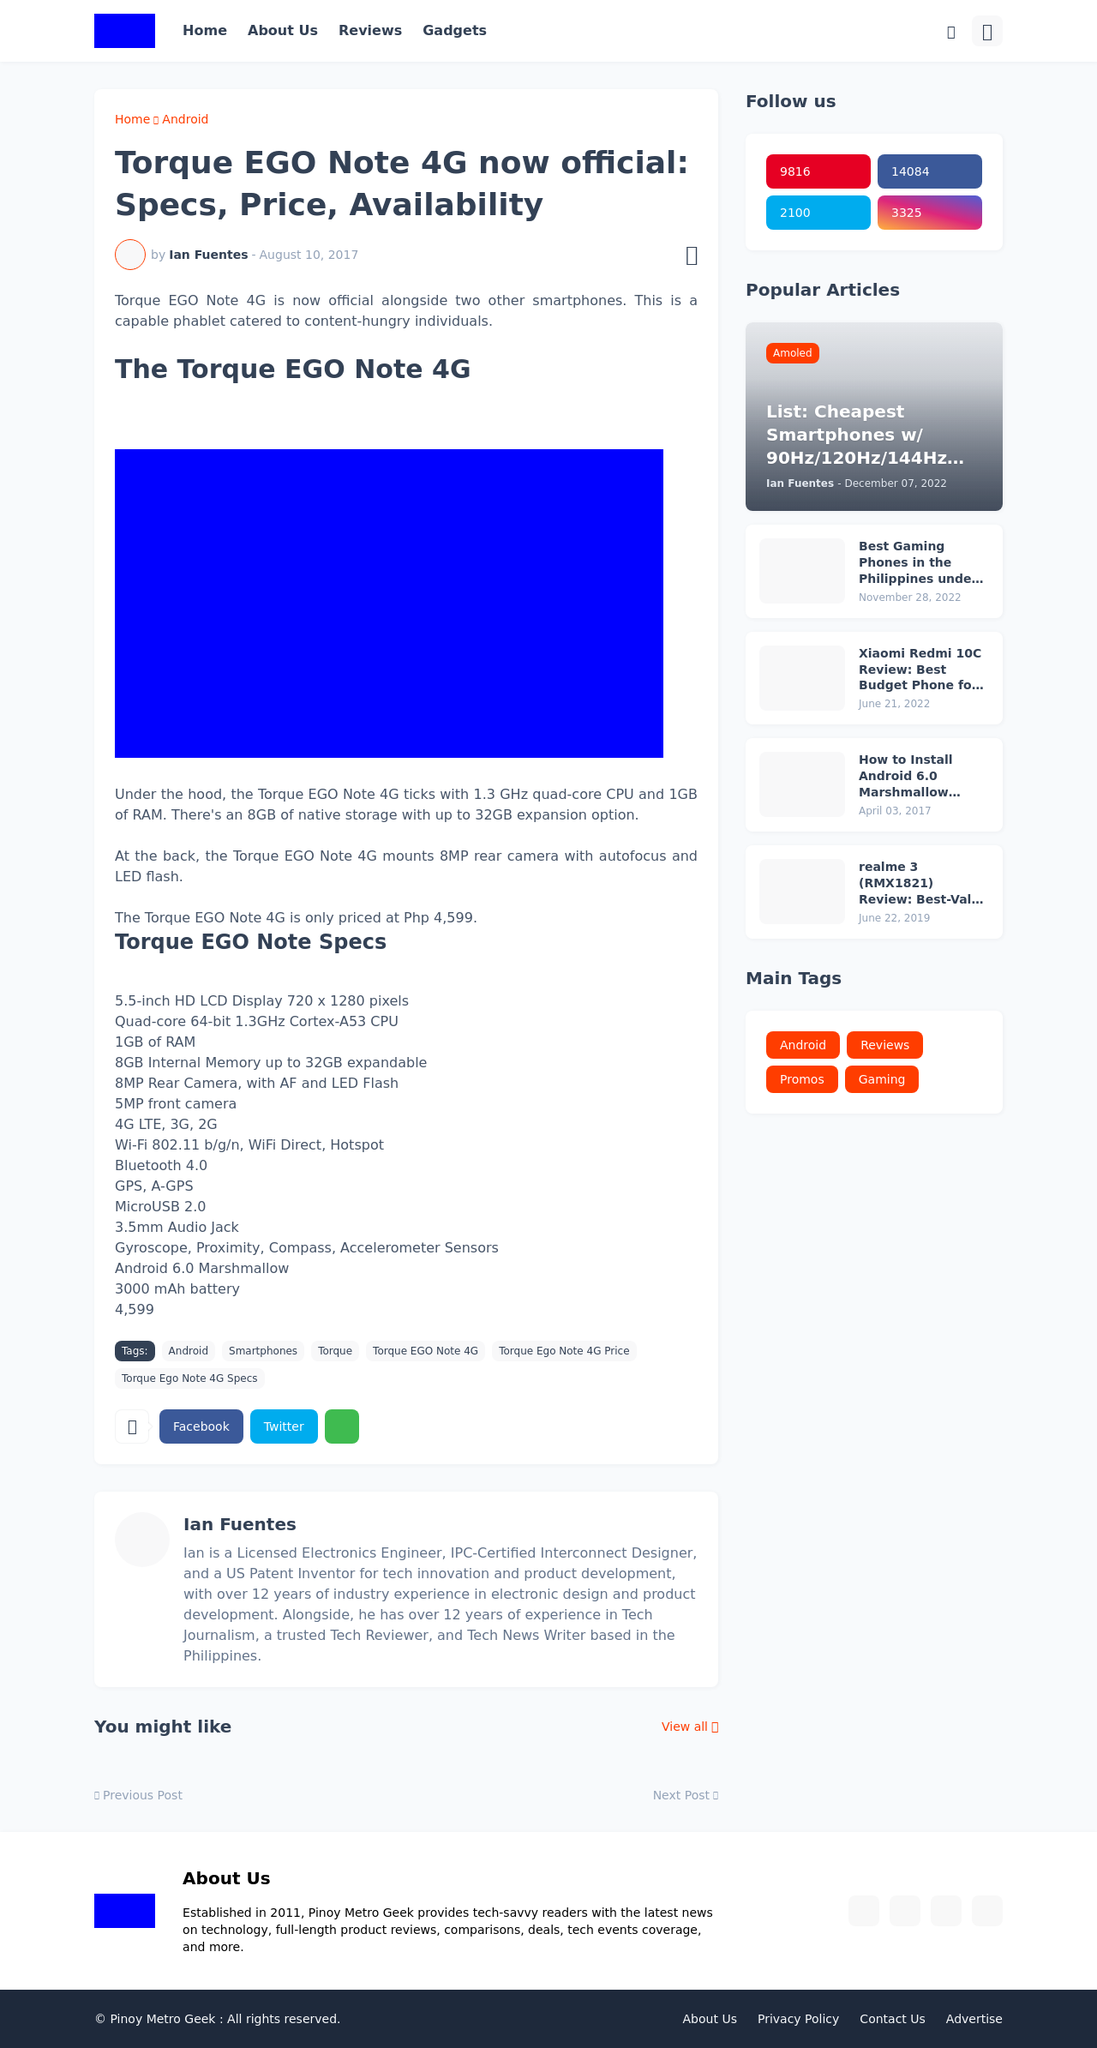How can this website be optimized for better performance? Optimizing this website for better performance could involve minifying CSS and JavaScript files to reduce their size and thus decrease load times. Leveraging browser caching, optimizing images to reduce their file size without losing quality, and using a Content Delivery Network (CDN) to serve content from locations closer to the users can also enhance performance.  What SEO techniques would be effective for this type of website? Effective SEO techniques for this type of website would include using keyword-rich titles and meta descriptions that are relevant to the content. Structuring content with proper header tags, ensuring mobile-friendliness, and securing quality backlinks from reputable sites would also boost its search engine rankings. Regularly updating the site with fresh, relevant content can further enhance its SEO. 